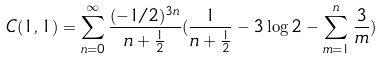<formula> <loc_0><loc_0><loc_500><loc_500>C ( 1 , 1 ) = \sum _ { n = 0 } ^ { \infty } \frac { ( - 1 / 2 ) ^ { 3 n } } { n + \frac { 1 } { 2 } } ( \frac { 1 } { n + \frac { 1 } { 2 } } - 3 \log 2 - \sum _ { m = 1 } ^ { n } \frac { 3 } { m } )</formula> 